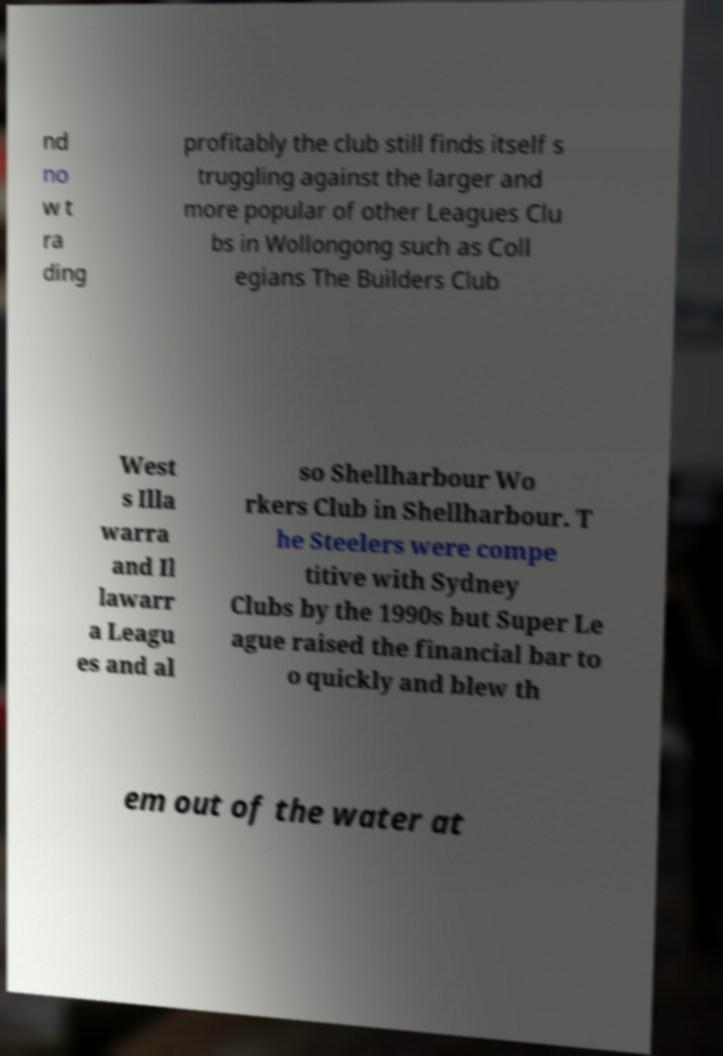Could you extract and type out the text from this image? nd no w t ra ding profitably the club still finds itself s truggling against the larger and more popular of other Leagues Clu bs in Wollongong such as Coll egians The Builders Club West s Illa warra and Il lawarr a Leagu es and al so Shellharbour Wo rkers Club in Shellharbour. T he Steelers were compe titive with Sydney Clubs by the 1990s but Super Le ague raised the financial bar to o quickly and blew th em out of the water at 